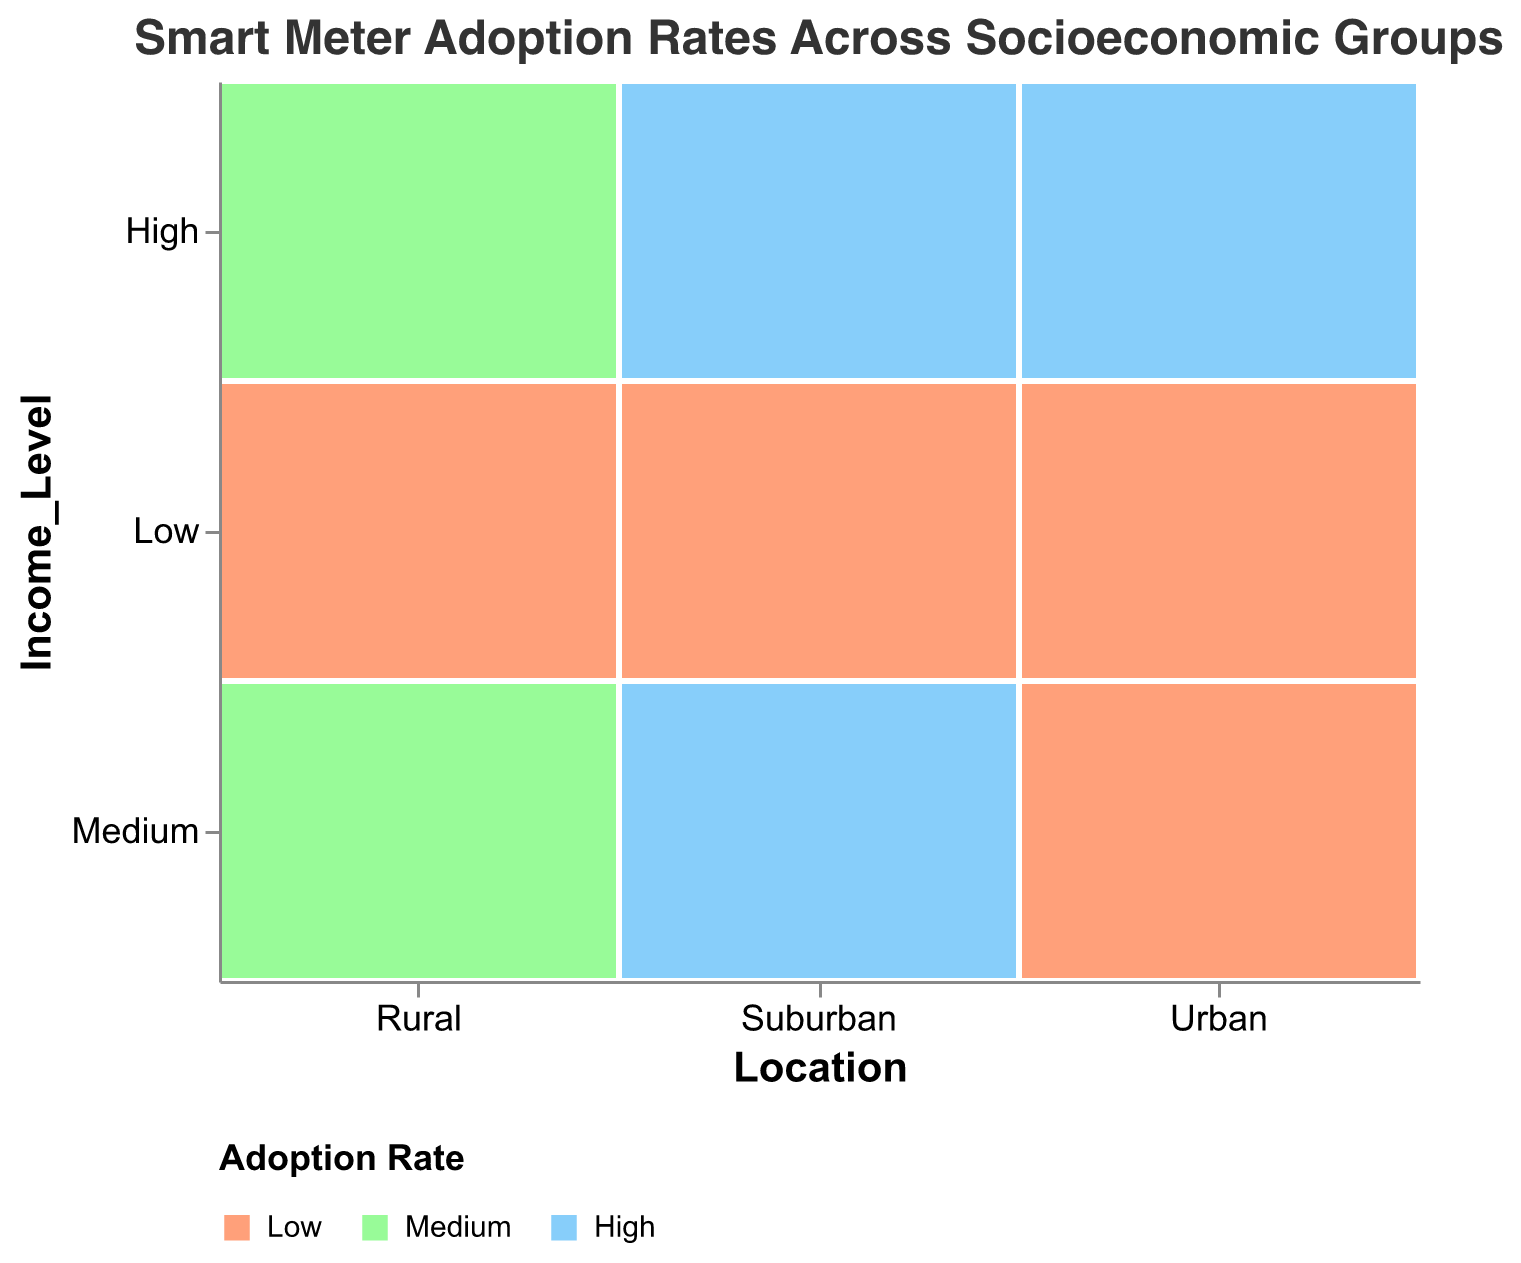What's the title of the figure? The title is written at the top of the figure. It states "Smart Meter Adoption Rates Across Socioeconomic Groups".
Answer: Smart Meter Adoption Rates Across Socioeconomic Groups What kind of data is represented by the x-axis? The x-axis of the figure is labeled "Location" and it categorizes the data into "Urban", "Rural", and "Suburban".
Answer: Location Which color represents the highest adoption rate? The color scale legend displays the mapping between colors and adoption rates. The light blue color corresponds to the high adoption rate.
Answer: Light blue How many income levels are shown for rural areas? The y-axis breaks down by income levels, and by aligning with the "Rural" category on the x-axis, we can count three income levels: Low, Medium, and High.
Answer: Three Which education level is most commonly associated with low adoption rates in urban areas? By examining the urban category on the x-axis and looking specifically at the segments colored according to the low adoption rate (salmon color), we note that these are most often associated with "High School" education levels.
Answer: High School Compare the adoption rates between high-income levels in urban and suburban areas. For high-income levels in the urban and suburban columns, the rectangles are colored light blue and of large size, indicating 'High' adoption rate. Both areas have high adoption rates for high-income levels.
Answer: Equal In rural areas, what is the relationship between education level and adoption rates? By analyzing the rural area segment, we observe that higher education levels such as 'College Degree' correspond with medium adoption rates (light green), whereas lower education levels (High School, No Degree) correspond with low adoption rates (salmon color).
Answer: Higher education levels have higher adoption rates Which location has the most diverse education levels for high-income adopters? By looking at the high-income levels on the y-axis and comparing the sizes within Urban, Suburban, and Rural sections, the Urban area shows the largest representation of different education levels ('College Degree', 'Graduate Degree', 'High School').
Answer: Urban Which location-income group has no high adoption rate? First, isolate the groups by location and income level on the x and y axes, respectively. The medium-income rural group does not contain any light blue color representation, indicating that it has no high adoption rate.
Answer: Medium-income Rural Is there any location-income group where all levels of adoption rates are seen? By checking all combinations of location and income levels on the x and y axes, the medium-income urban group shows all three colors, meaning 'High', 'Medium', and 'Low' adoption rates are all present.
Answer: Medium-income Urban 